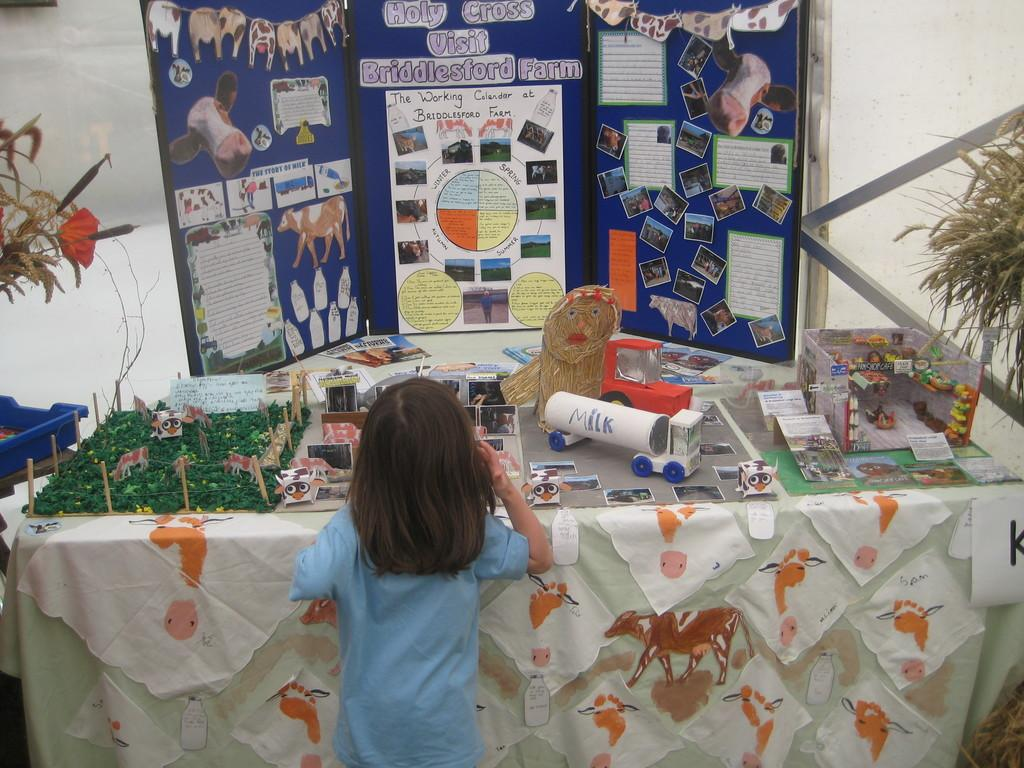Who is present in the image? There is a girl in the image. What is the girl doing in the image? The girl is watching crafts. Where are the crafts located in the image? The crafts are on a table. What type of cough medicine is visible on the table with the crafts? There is no cough medicine present in the image; it only features a girl watching crafts on a table. What is the purpose of the paste in the image? There is no mention of paste in the image; it only features a girl watching crafts on a table. 